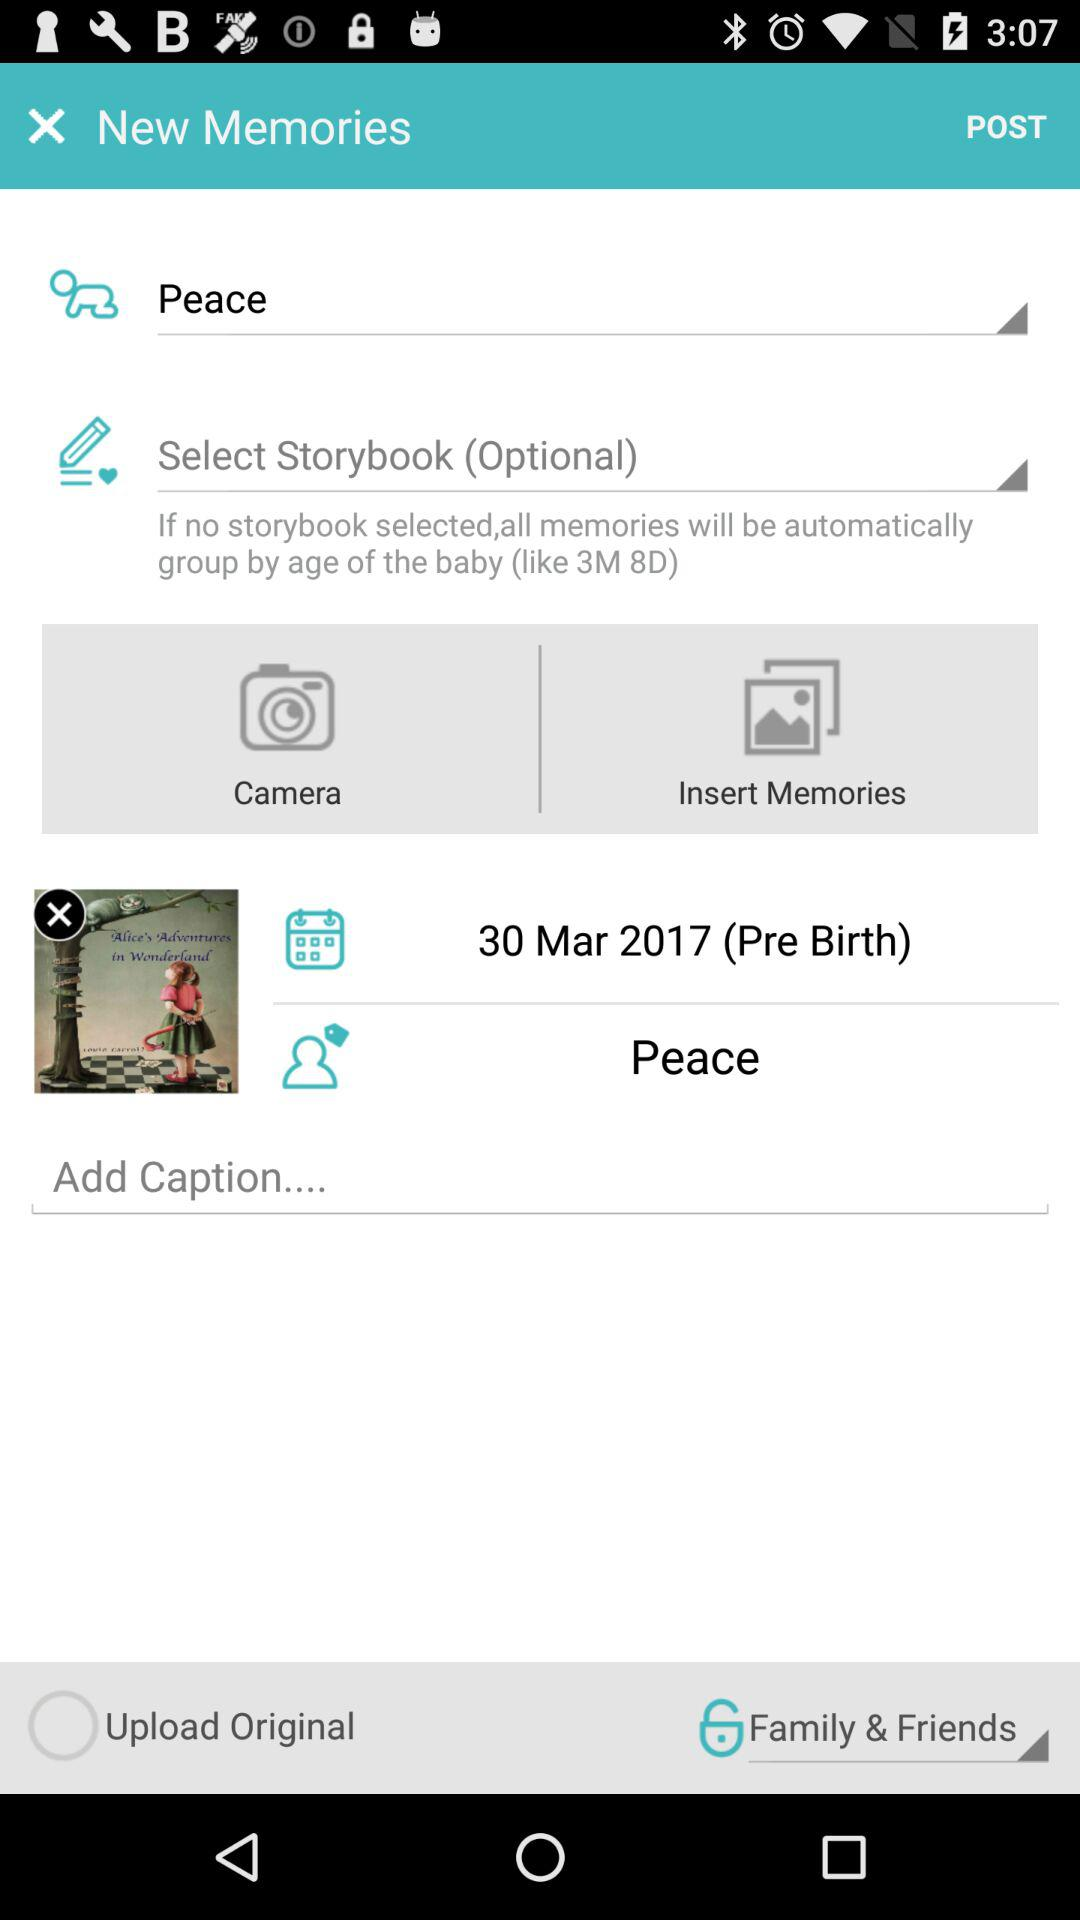What is the pre-birth date? The pre-birth date is March 30, 2017. 